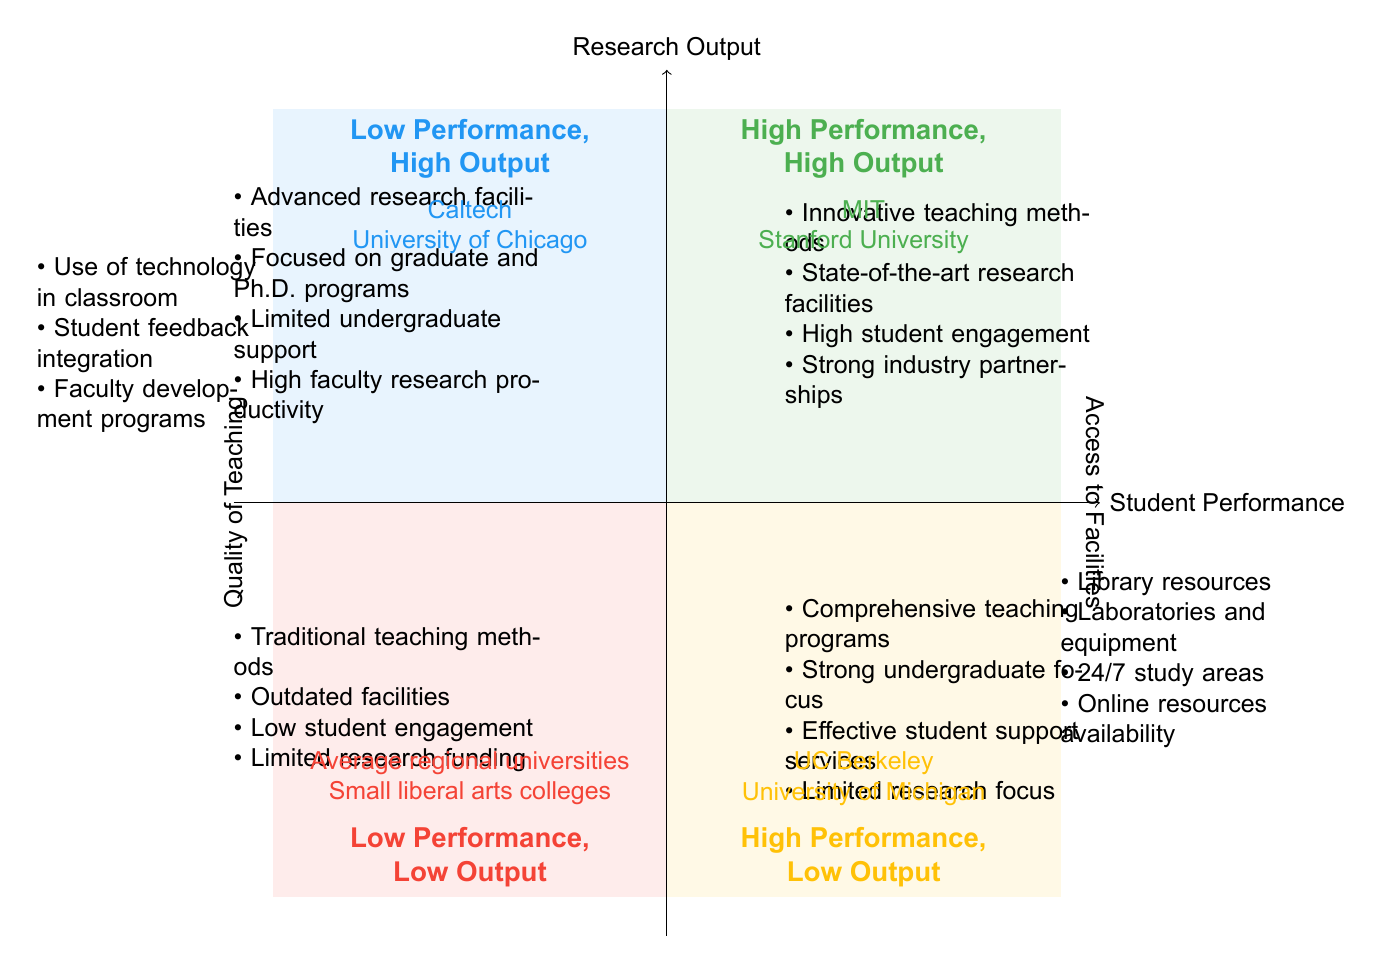What are the examples of institutions in the High Performance, High Output quadrant? The High Performance, High Output quadrant contains examples such as MIT and Stanford University. This can be found in the label area of that specific quadrant in the diagram.
Answer: MIT, Stanford University What characteristics are associated with the Low Performance, High Output quadrant? The Low Performance, High Output quadrant lists characteristics such as advanced research facilities and focused on graduate and Ph.D. programs. These points can be found in the characteristics section of that quadrant.
Answer: Advanced research facilities, focused on graduate and Ph.D. programs Which quadrant includes universities focused on comprehensive teaching programs? The quadrant that includes universities focused on comprehensive teaching programs is the Bottom Right quadrant, labeled High Performance, Low Output. This information is determined by the characteristics outlined for each quadrant.
Answer: High Performance, Low Output How many quadrants are identified in this chart? The chart identifies four quadrants: High Performance, High Output; Low Performance, High Output; High Performance, Low Output; and Low Performance, Low Output. This total is calculated by counting the quadrants represented in the diagram.
Answer: Four What is the primary focus of institutions categorized in the Low Performance, Low Output quadrant? Institutions in the Low Performance, Low Output quadrant are characterized by traditional teaching methods and outdated facilities. By examining this quadrant's listed characteristics, we can derive its primary focus.
Answer: Traditional teaching methods, outdated facilities Which quadrant is characterized by strong undergraduate focus? The quadrant characterized by a strong undergraduate focus is the Bottom Right quadrant, known as High Performance, Low Output. This is established by checking the specific characteristics listed in that quadrant.
Answer: High Performance, Low Output Name one key background element related to Access to Facilities. One key background element related to Access to Facilities includes library resources. It can be found in the segment dedicated to background elements in the diagram.
Answer: Library resources Which university is an example from the Low Performance, Low Output quadrant? An example from the Low Performance, Low Output quadrant is small liberal arts colleges. This information is directly referenced in the examples section of that quadrant.
Answer: Small liberal arts colleges 